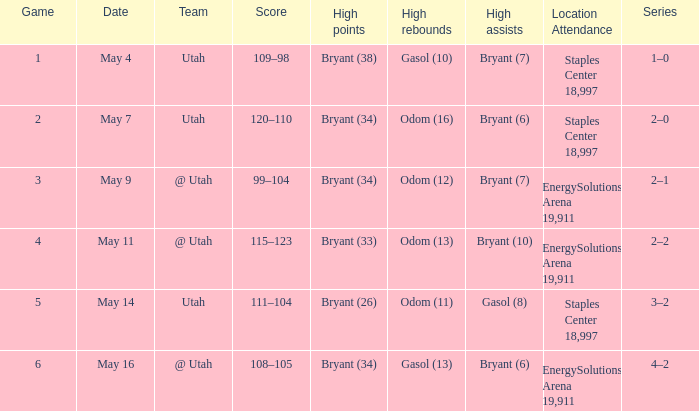What is the High rebounds with a Series with 4–2? Gasol (13). 